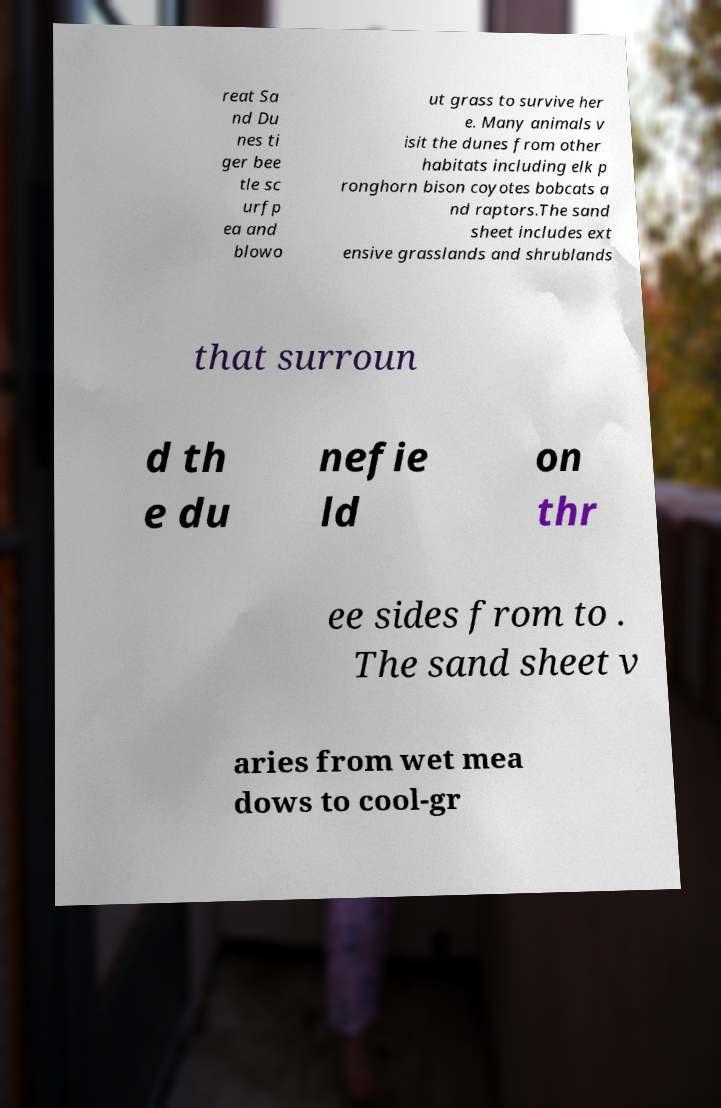Please identify and transcribe the text found in this image. reat Sa nd Du nes ti ger bee tle sc urfp ea and blowo ut grass to survive her e. Many animals v isit the dunes from other habitats including elk p ronghorn bison coyotes bobcats a nd raptors.The sand sheet includes ext ensive grasslands and shrublands that surroun d th e du nefie ld on thr ee sides from to . The sand sheet v aries from wet mea dows to cool-gr 